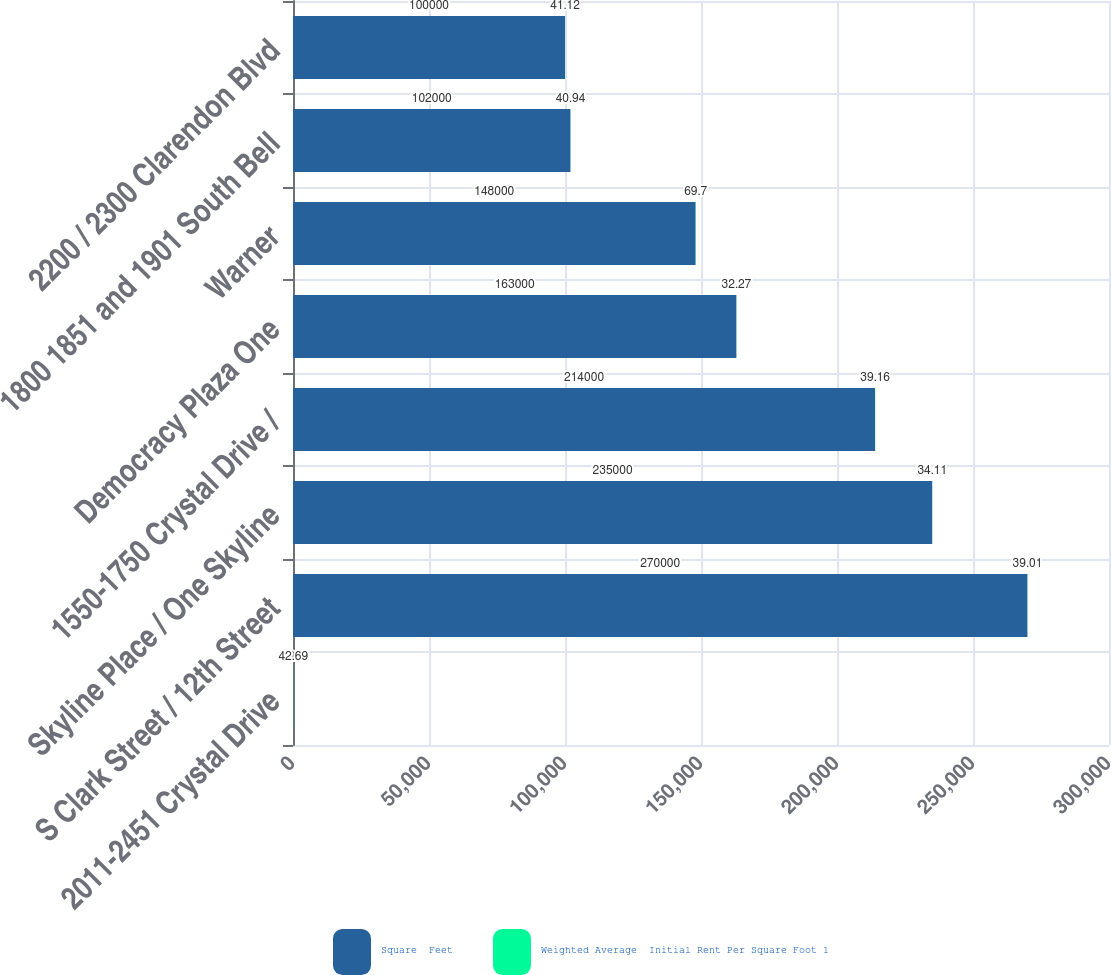<chart> <loc_0><loc_0><loc_500><loc_500><stacked_bar_chart><ecel><fcel>2011-2451 Crystal Drive<fcel>S Clark Street / 12th Street<fcel>Skyline Place / One Skyline<fcel>1550-1750 Crystal Drive /<fcel>Democracy Plaza One<fcel>Warner<fcel>1800 1851 and 1901 South Bell<fcel>2200 / 2300 Clarendon Blvd<nl><fcel>Square  Feet<fcel>69.7<fcel>270000<fcel>235000<fcel>214000<fcel>163000<fcel>148000<fcel>102000<fcel>100000<nl><fcel>Weighted Average  Initial Rent Per Square Foot 1<fcel>42.69<fcel>39.01<fcel>34.11<fcel>39.16<fcel>32.27<fcel>69.7<fcel>40.94<fcel>41.12<nl></chart> 